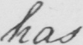Transcribe the text shown in this historical manuscript line. has 